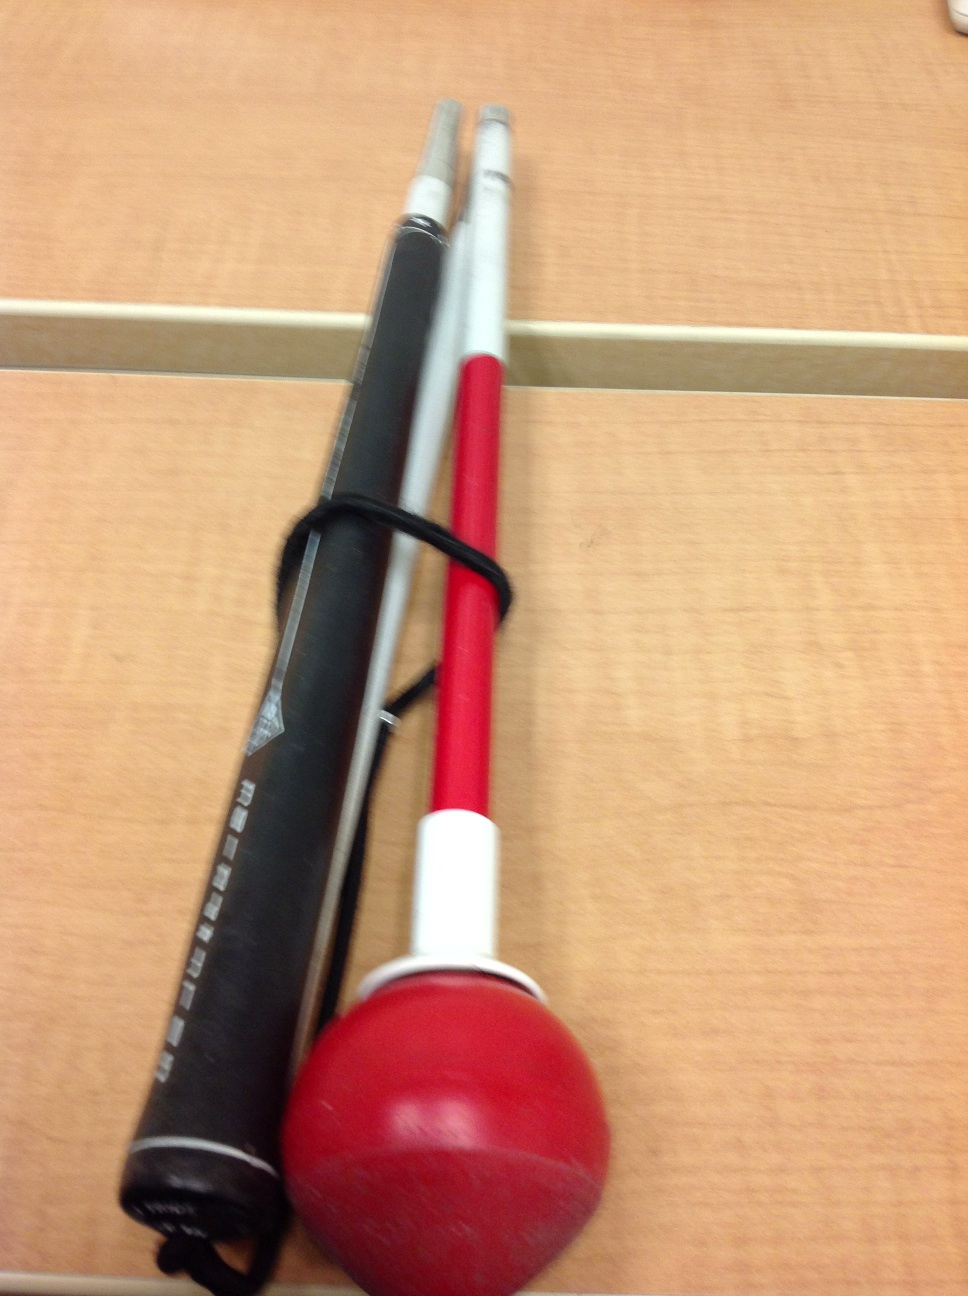What is this? from Vizwiz swing trainer 